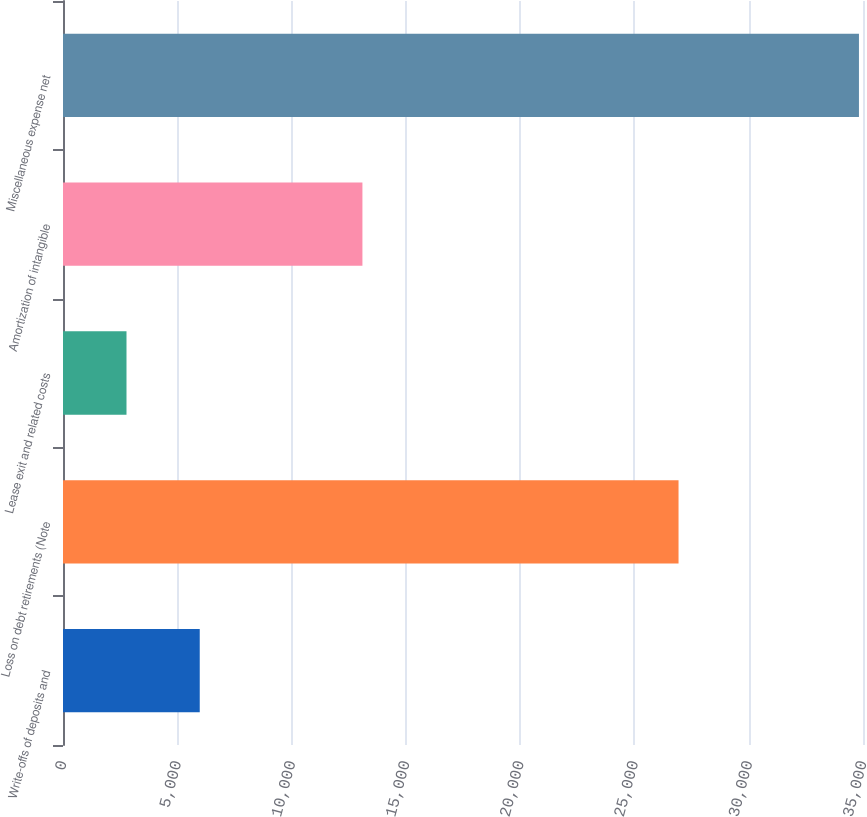<chart> <loc_0><loc_0><loc_500><loc_500><bar_chart><fcel>Write-offs of deposits and<fcel>Loss on debt retirements (Note<fcel>Lease exit and related costs<fcel>Amortization of intangible<fcel>Miscellaneous expense net<nl><fcel>5982.5<fcel>26930<fcel>2778<fcel>13100<fcel>34823<nl></chart> 